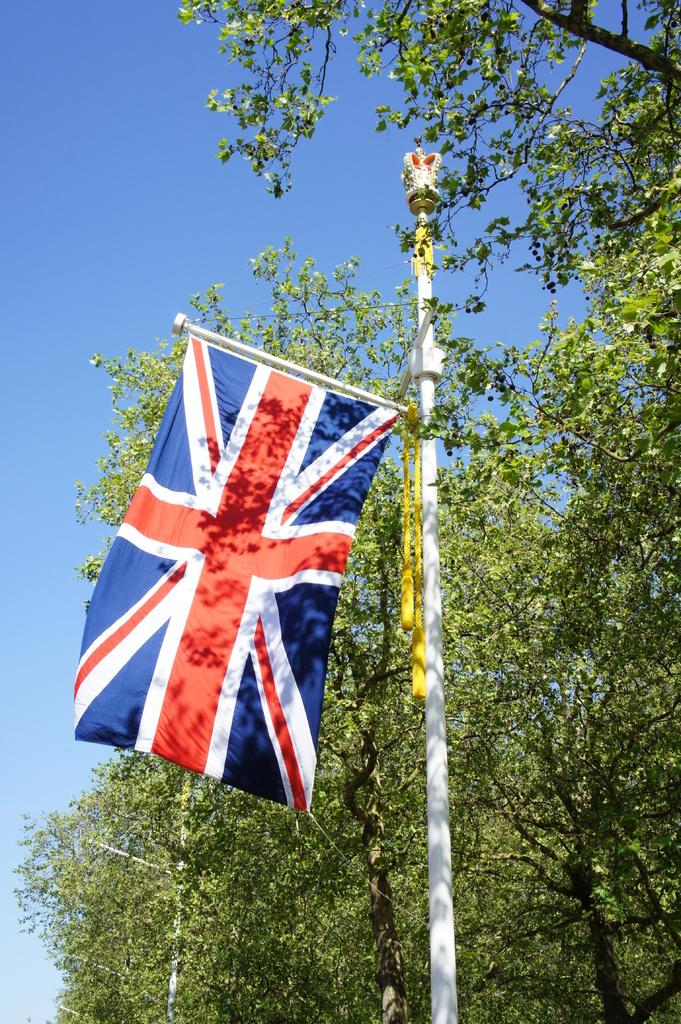What is attached to the pole in the image? There is a flag attached to the pole in the image. What type of vegetation is on the right side of the image? There are trees on the right side of the image. What is visible at the top of the image? The sky is visible at the top of the image. How many trucks are parked near the trees in the image? There are no trucks present in the image; it features a pole with a flag and trees on the right side. What book is the person reading in the image? There is no person reading a book in the image; it only shows a pole with a flag and trees. 